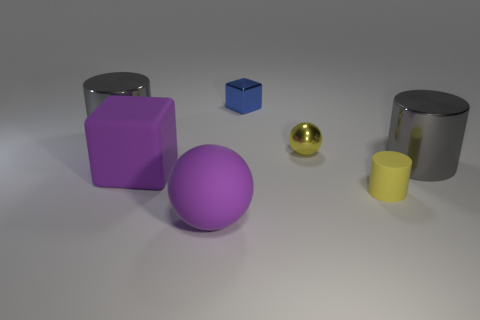Add 1 blue metal objects. How many objects exist? 8 Subtract all blocks. How many objects are left? 5 Subtract all gray matte objects. Subtract all small yellow cylinders. How many objects are left? 6 Add 2 tiny yellow metal spheres. How many tiny yellow metal spheres are left? 3 Add 1 cylinders. How many cylinders exist? 4 Subtract 1 purple blocks. How many objects are left? 6 